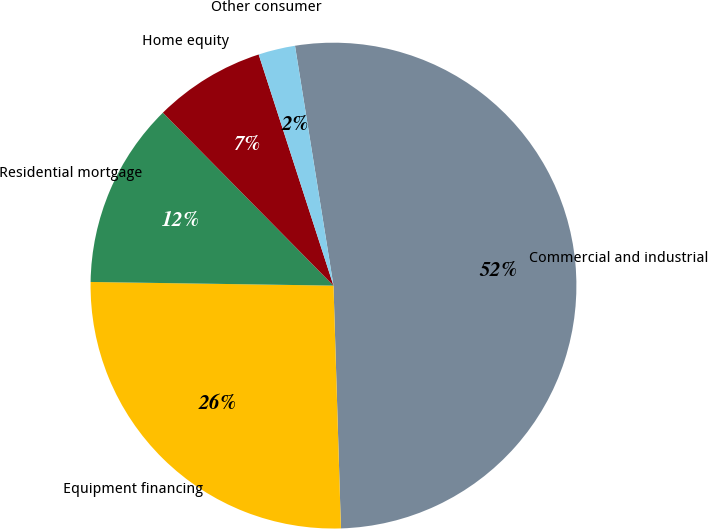<chart> <loc_0><loc_0><loc_500><loc_500><pie_chart><fcel>Commercial and industrial<fcel>Equipment financing<fcel>Residential mortgage<fcel>Home equity<fcel>Other consumer<nl><fcel>52.05%<fcel>25.73%<fcel>12.37%<fcel>7.41%<fcel>2.45%<nl></chart> 